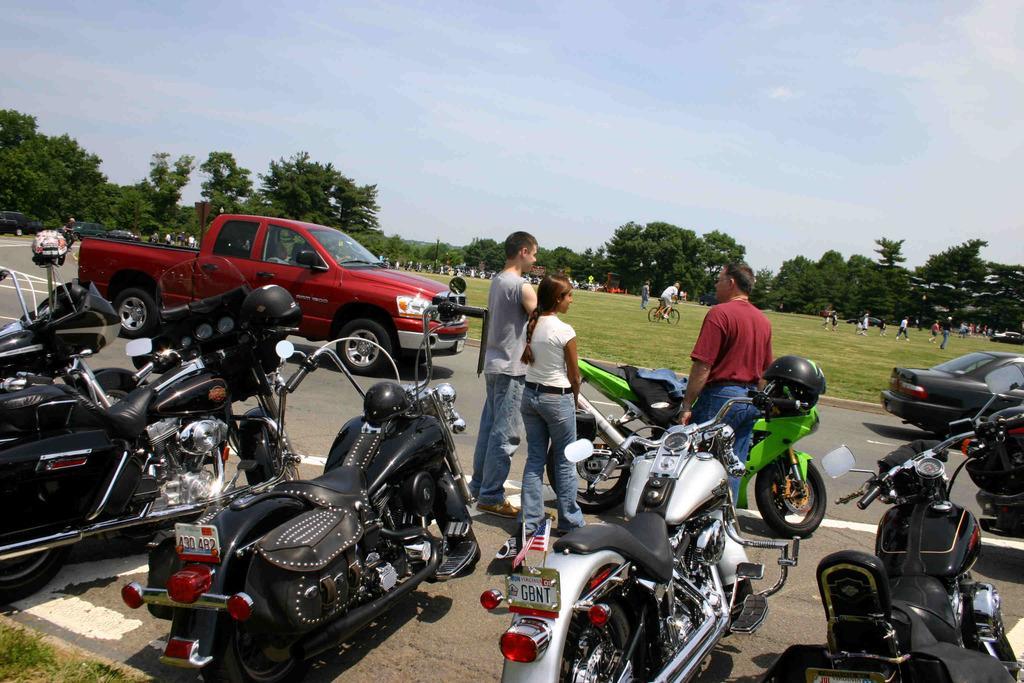Can you describe this image briefly? In this image we can see many motorcycles. Also there are few people. And there are other vehicles on the road. In the back there is grass lawn. There are many people. In the background there are trees. And there is sky with clouds. 